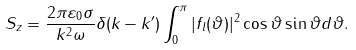<formula> <loc_0><loc_0><loc_500><loc_500>S _ { z } = \frac { 2 \pi \varepsilon _ { 0 } \sigma } { k ^ { 2 } \omega } \delta ( k - k ^ { \prime } ) \int _ { 0 } ^ { \pi } | f _ { l } ( \vartheta ) | ^ { 2 } \cos \vartheta \sin \vartheta d \vartheta .</formula> 